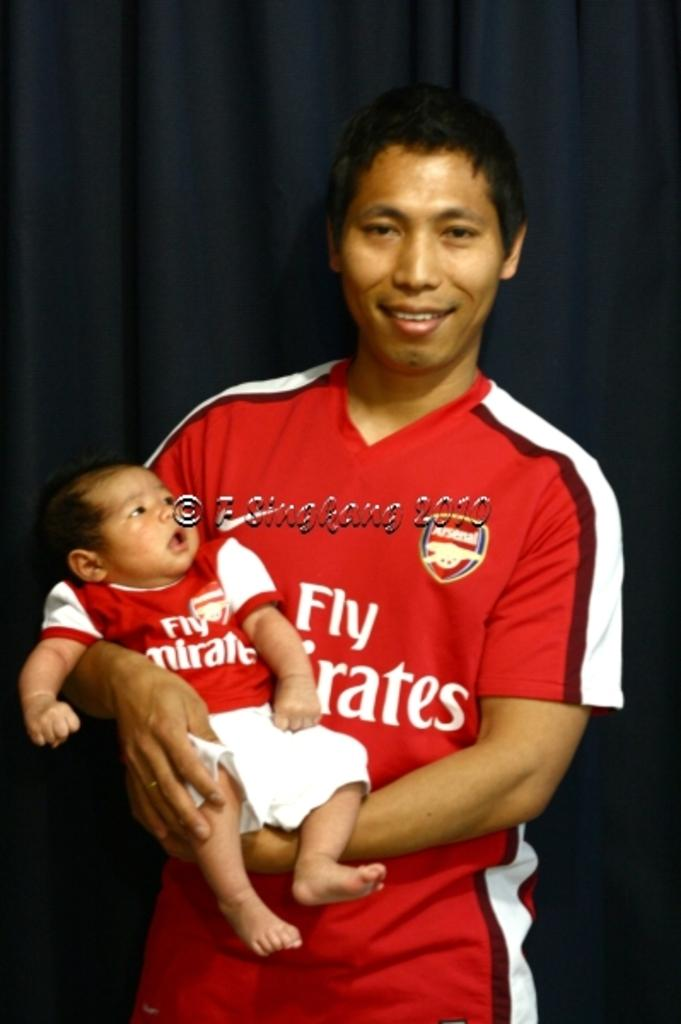What is the main subject of the image? There is a person standing in the image. What is the person doing in the image? The person is carrying a baby. What can be seen in the background of the image? There is a curtain visible on the backside of the image. What is present in the center of the image? There is some text in the center of the image. What is the rate of growth for the plant in the image? There is no plant present in the image, so it is not possible to determine the rate of growth. 